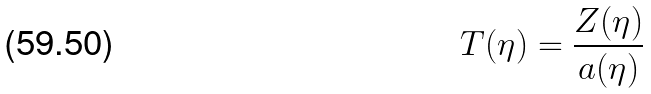<formula> <loc_0><loc_0><loc_500><loc_500>T ( \eta ) = { \frac { Z ( \eta ) } { a ( \eta ) } }</formula> 